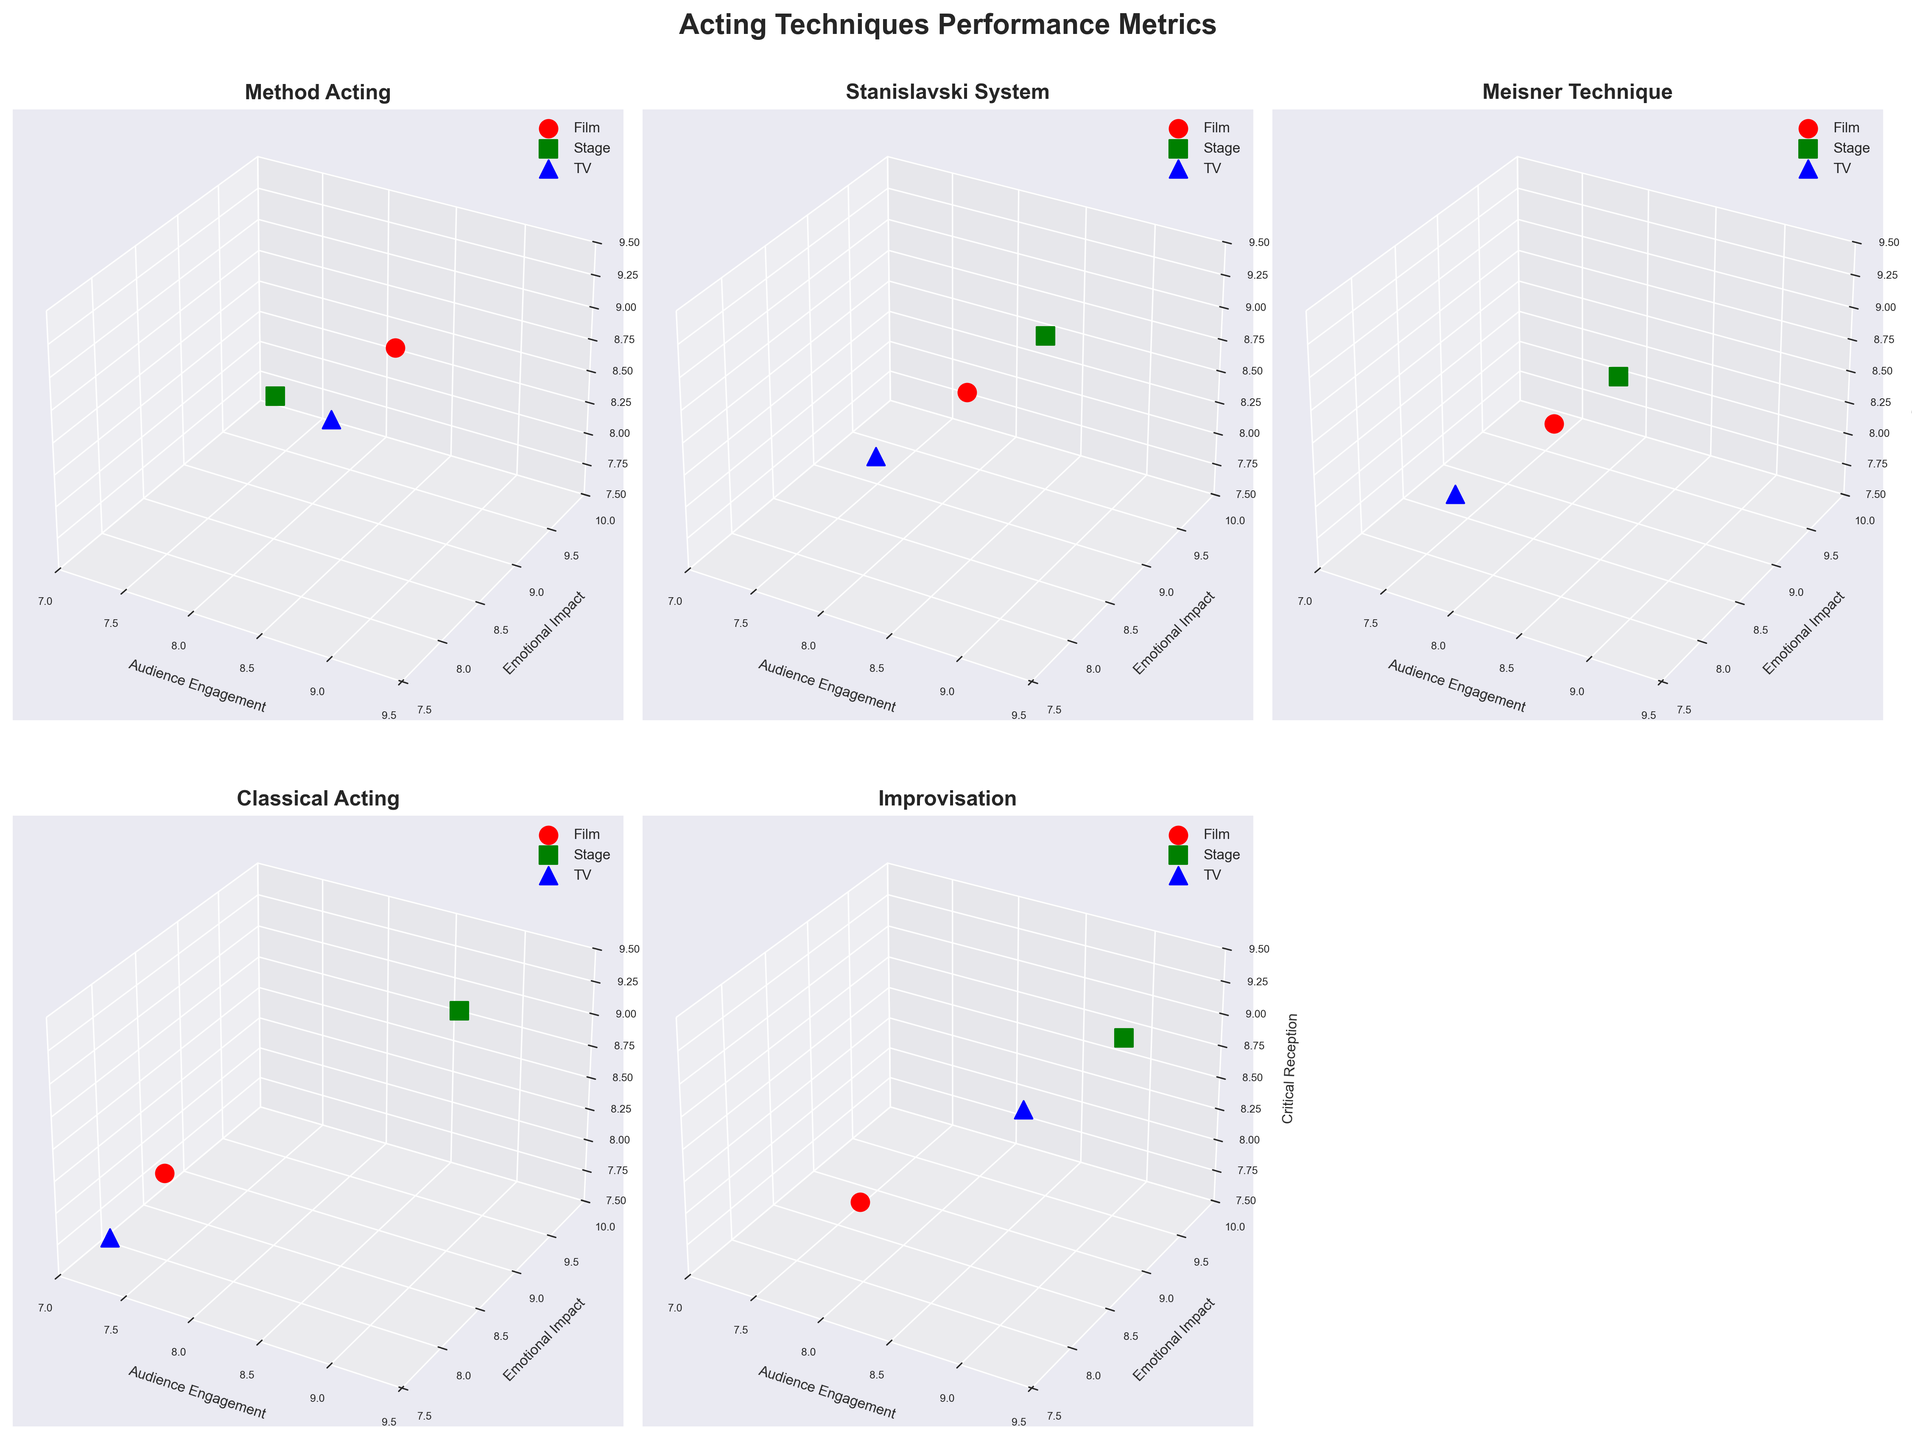What's the title of the figure? The title of a figure is typically found at the top. According to the code, it is set to 'Acting Techniques Performance Metrics'.
Answer: Acting Techniques Performance Metrics Which technique shows the highest Audience Engagement in the Film medium? For each subplot, find the 'Film' medium and check the Audience Engagement values across techniques. Method Acting has an Audience Engagement value of 8.5, higher than others.
Answer: Method Acting What's the range of Audience Engagement values shown for Improvisation? In the Improvisation subplot, observe the points for different mediums. The values are 7.8 (Film), 9.1 (Stage), and 8.6 (TV). So, the range is [7.8, 9.1].
Answer: [7.8, 9.1] For Method Acting, which medium has the highest Critical Reception? In the Method Acting subplot, compare the Critical Reception values for Film (8.8), Stage (8.5), and TV (8.3). Film has the highest value.
Answer: Film Which acting technique performs the best across all mediums, considering Emotional Impact? Calculate the average Emotional Impact for each technique across all mediums. Method Acting: (9.2 + 8.7 + 8.9)/3 = 8.93; Stanislavski: (8.8 + 9.1 + 8.5)/3 = 8.8; Meisner: (8.6 + 8.9 + 8.2)/3 = 8.57; Classical: (8.0 + 9.3 + 7.8)/3 = 8.37; Improvisation: (8.3 + 9.4 + 9)/3 = 8.9. Method Acting has the highest average, 8.93.
Answer: Method Acting Which two techniques have the closest Emotional Impact values in the Stage medium? Compare the Stage Emotional Impact values for all techniques: Method Acting (8.7), Stanislavski (9.1), Meisner (8.9), Classical Acting (9.3), Improvisation (9.4). Stanislavski (9.1) and Meisner (8.9) are the closest with a difference of 0.2.
Answer: Stanislavski System and Meisner Technique Which medium has the most consistent Critical Reception across different techniques? Calculate the variance in Critical Reception for each medium using information from different subplots. Film: 0.09, Stage: 0.07, TV: 0.07. Stage and TV both have the lowest variance, hence most consistent.
Answer: Stage and TV How does Method Acting compare to Stanislavski System in terms of Audience Engagement on TV? Identify the Audience Engagement values on TV for both techniques. Method Acting has 8.2, Stanislavski System has 7.8. Method Acting has a higher value.
Answer: Method Acting Does the Stage medium always have the highest Emotional Impact compared to Film and TV for all techniques? Compare the Emotional Impact across mediums for each technique. In each subplot, the Stage medium indeed always has the highest value.
Answer: Yes 